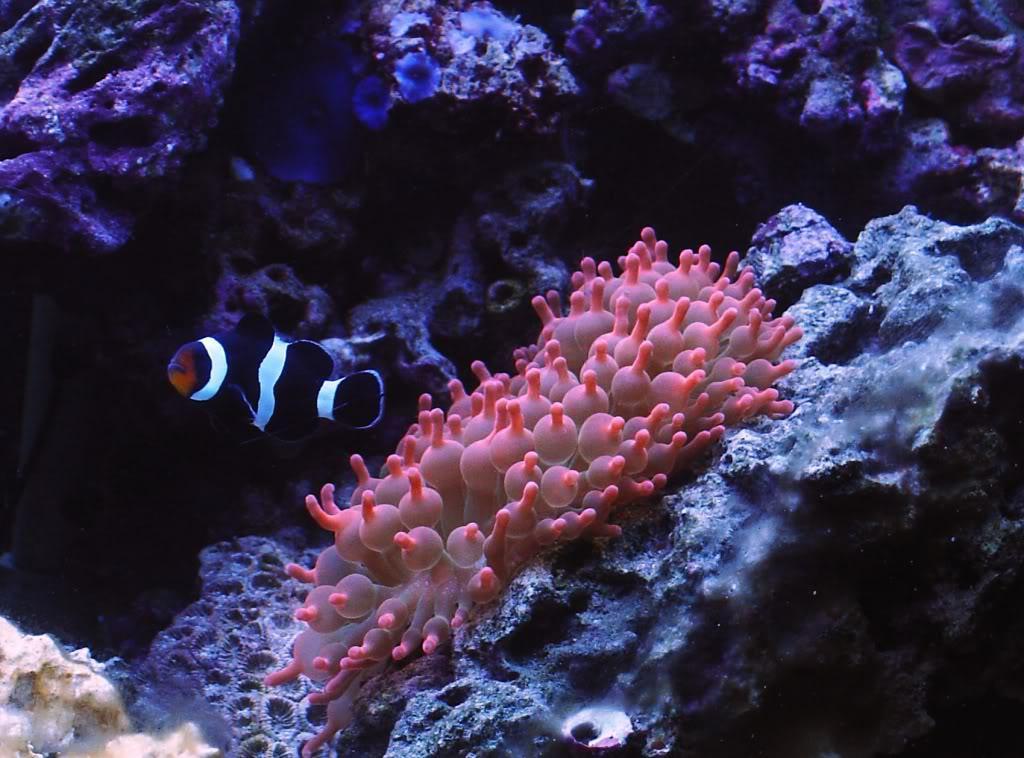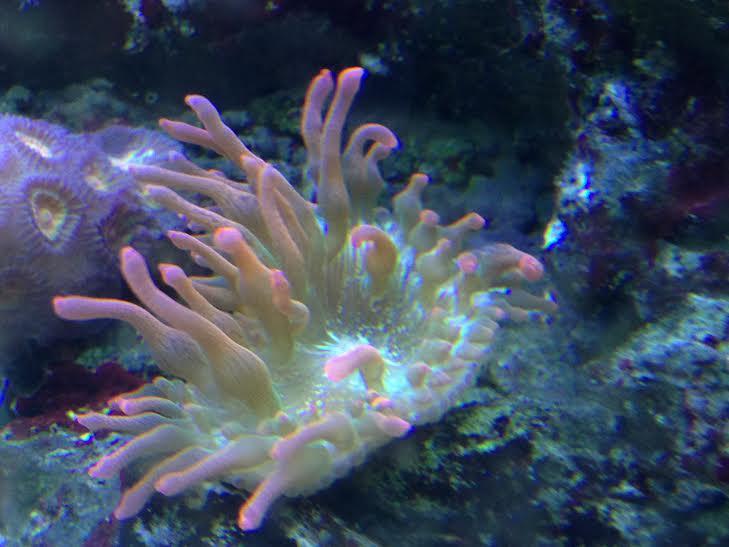The first image is the image on the left, the second image is the image on the right. Examine the images to the left and right. Is the description "One of the anemones is spherical in shape." accurate? Answer yes or no. No. 